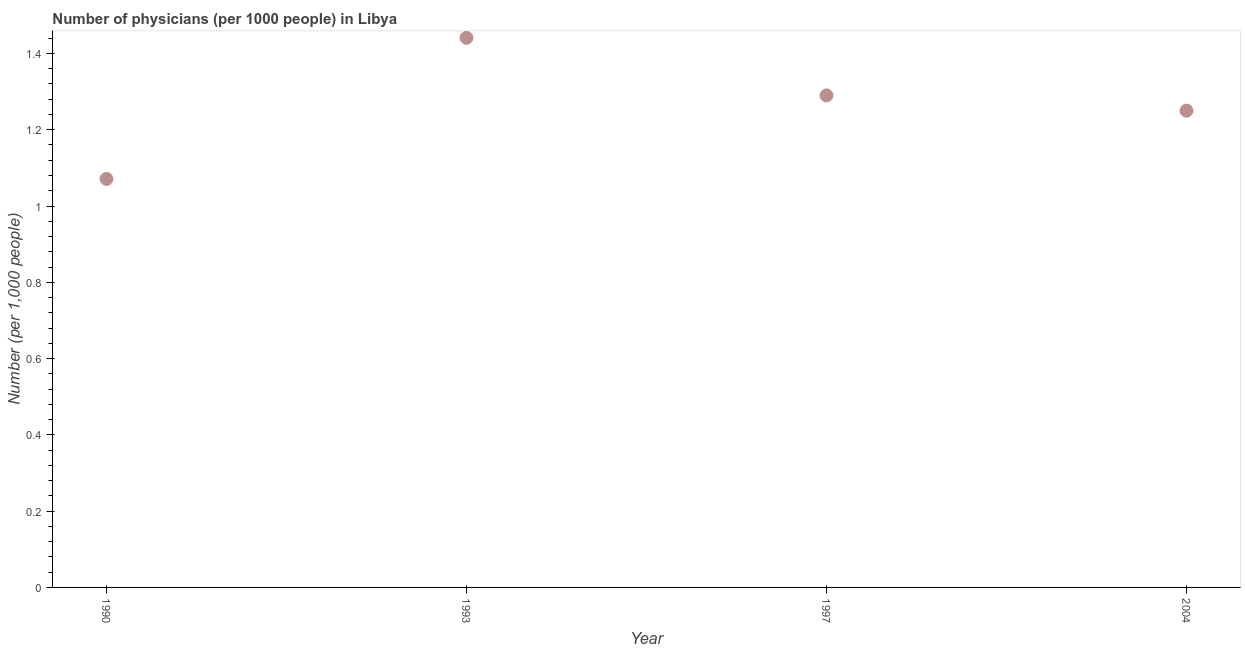What is the number of physicians in 1993?
Your response must be concise. 1.44. Across all years, what is the maximum number of physicians?
Keep it short and to the point. 1.44. Across all years, what is the minimum number of physicians?
Your answer should be compact. 1.07. What is the sum of the number of physicians?
Offer a very short reply. 5.05. What is the difference between the number of physicians in 1990 and 1993?
Your answer should be compact. -0.37. What is the average number of physicians per year?
Ensure brevity in your answer.  1.26. What is the median number of physicians?
Make the answer very short. 1.27. What is the ratio of the number of physicians in 1990 to that in 2004?
Provide a succinct answer. 0.86. Is the difference between the number of physicians in 1993 and 2004 greater than the difference between any two years?
Your response must be concise. No. What is the difference between the highest and the second highest number of physicians?
Your answer should be compact. 0.15. Is the sum of the number of physicians in 1993 and 1997 greater than the maximum number of physicians across all years?
Offer a terse response. Yes. What is the difference between the highest and the lowest number of physicians?
Provide a succinct answer. 0.37. Does the number of physicians monotonically increase over the years?
Offer a very short reply. No. How many dotlines are there?
Make the answer very short. 1. How many years are there in the graph?
Offer a very short reply. 4. What is the difference between two consecutive major ticks on the Y-axis?
Ensure brevity in your answer.  0.2. Does the graph contain grids?
Provide a short and direct response. No. What is the title of the graph?
Offer a terse response. Number of physicians (per 1000 people) in Libya. What is the label or title of the X-axis?
Give a very brief answer. Year. What is the label or title of the Y-axis?
Your answer should be compact. Number (per 1,0 people). What is the Number (per 1,000 people) in 1990?
Your answer should be very brief. 1.07. What is the Number (per 1,000 people) in 1993?
Make the answer very short. 1.44. What is the Number (per 1,000 people) in 1997?
Offer a very short reply. 1.29. What is the difference between the Number (per 1,000 people) in 1990 and 1993?
Provide a succinct answer. -0.37. What is the difference between the Number (per 1,000 people) in 1990 and 1997?
Keep it short and to the point. -0.22. What is the difference between the Number (per 1,000 people) in 1990 and 2004?
Give a very brief answer. -0.18. What is the difference between the Number (per 1,000 people) in 1993 and 1997?
Keep it short and to the point. 0.15. What is the difference between the Number (per 1,000 people) in 1993 and 2004?
Provide a short and direct response. 0.19. What is the ratio of the Number (per 1,000 people) in 1990 to that in 1993?
Make the answer very short. 0.74. What is the ratio of the Number (per 1,000 people) in 1990 to that in 1997?
Make the answer very short. 0.83. What is the ratio of the Number (per 1,000 people) in 1990 to that in 2004?
Offer a terse response. 0.86. What is the ratio of the Number (per 1,000 people) in 1993 to that in 1997?
Provide a short and direct response. 1.12. What is the ratio of the Number (per 1,000 people) in 1993 to that in 2004?
Provide a short and direct response. 1.15. What is the ratio of the Number (per 1,000 people) in 1997 to that in 2004?
Provide a short and direct response. 1.03. 